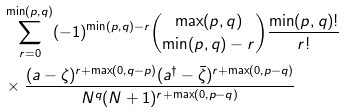Convert formula to latex. <formula><loc_0><loc_0><loc_500><loc_500>& \sum _ { r = 0 } ^ { \min ( p , q ) } ( - 1 ) ^ { \min ( p , q ) - r } { \max ( p , q ) \choose \min ( p , q ) - r } \frac { \min ( p , q ) ! } { r ! } \\ & \times \frac { ( a - \zeta ) ^ { r + \max ( 0 , q - p ) } ( a ^ { \dag } - \bar { \zeta } ) ^ { r + \max ( 0 , p - q ) } } { N ^ { q } ( N + 1 ) ^ { r + \max ( 0 , p - q ) } }</formula> 